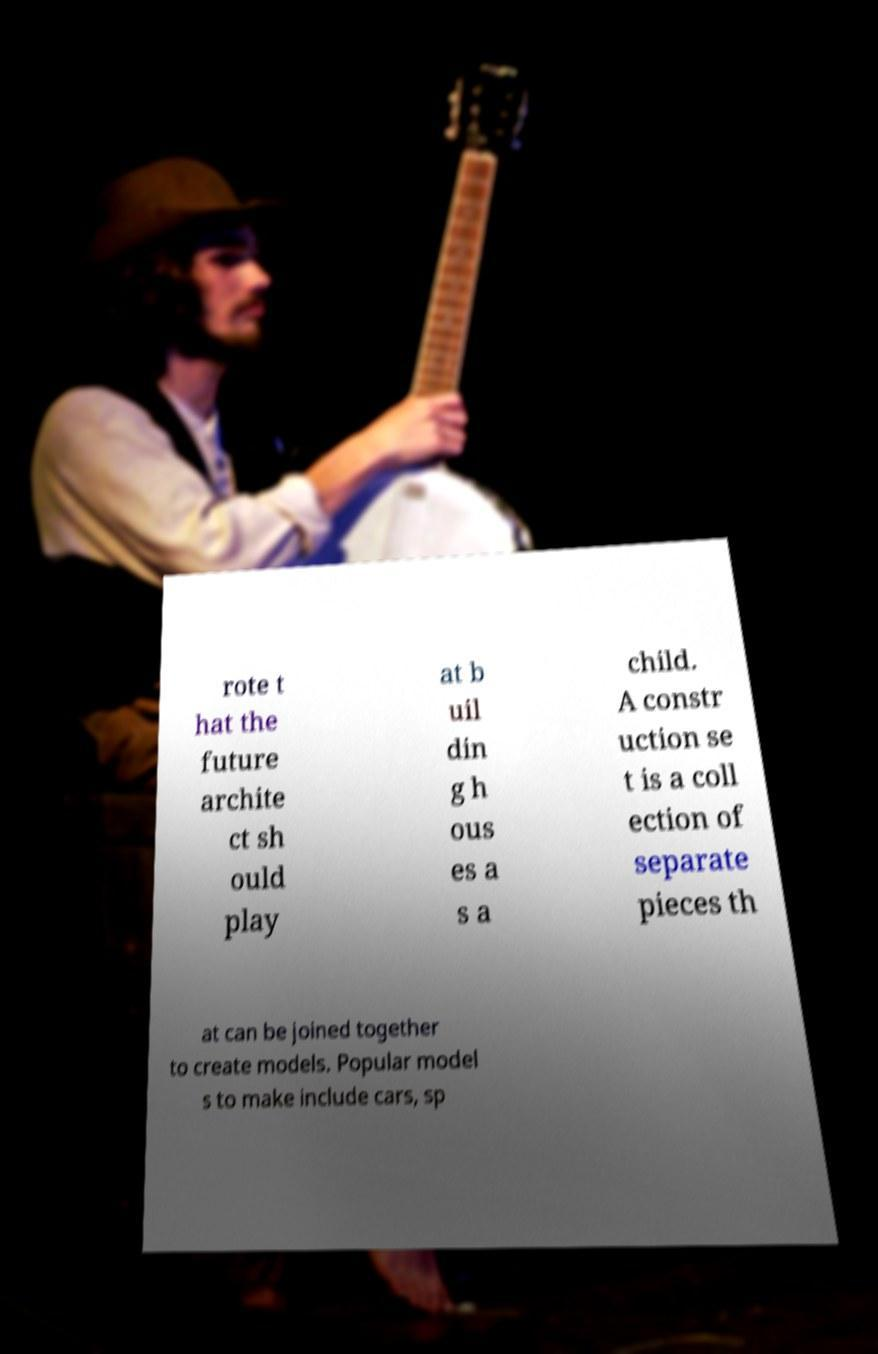Please identify and transcribe the text found in this image. rote t hat the future archite ct sh ould play at b uil din g h ous es a s a child. A constr uction se t is a coll ection of separate pieces th at can be joined together to create models. Popular model s to make include cars, sp 